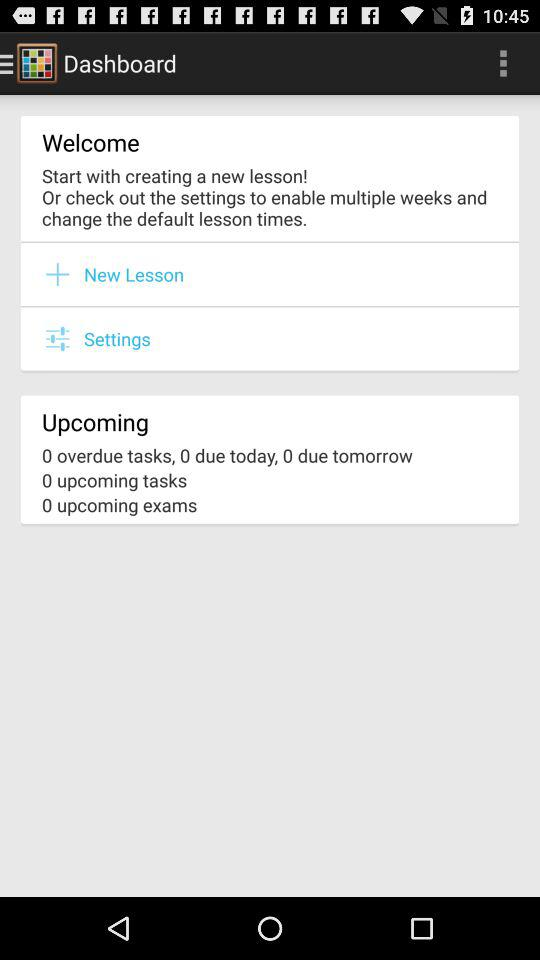How do you create a new lesson?
When the provided information is insufficient, respond with <no answer>. <no answer> 